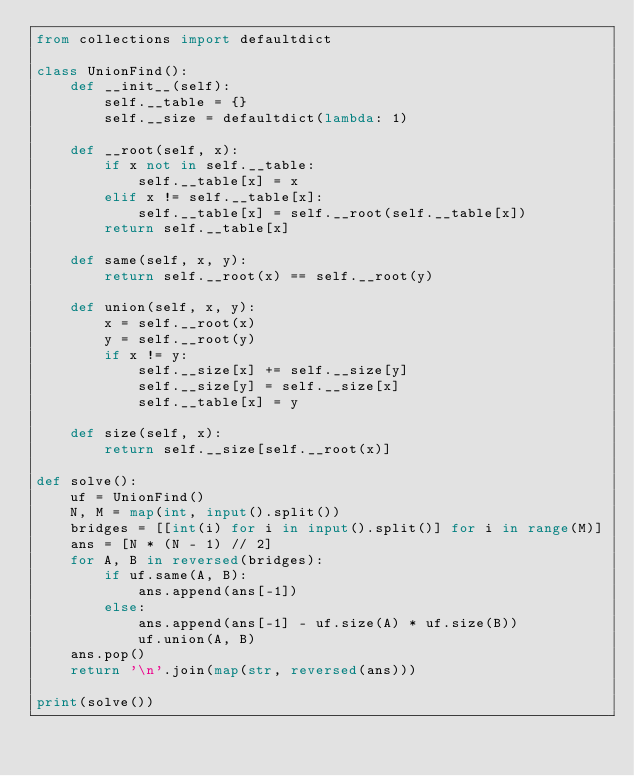Convert code to text. <code><loc_0><loc_0><loc_500><loc_500><_Python_>from collections import defaultdict

class UnionFind():
    def __init__(self):
        self.__table = {}
        self.__size = defaultdict(lambda: 1)

    def __root(self, x):
        if x not in self.__table:
            self.__table[x] = x
        elif x != self.__table[x]:
            self.__table[x] = self.__root(self.__table[x])
        return self.__table[x]

    def same(self, x, y):
        return self.__root(x) == self.__root(y)

    def union(self, x, y):
        x = self.__root(x)
        y = self.__root(y)
        if x != y:
            self.__size[x] += self.__size[y]
            self.__size[y] = self.__size[x]
            self.__table[x] = y

    def size(self, x):
        return self.__size[self.__root(x)]

def solve():
    uf = UnionFind()
    N, M = map(int, input().split())
    bridges = [[int(i) for i in input().split()] for i in range(M)]
    ans = [N * (N - 1) // 2]
    for A, B in reversed(bridges):
        if uf.same(A, B):
            ans.append(ans[-1])
        else:
            ans.append(ans[-1] - uf.size(A) * uf.size(B))
            uf.union(A, B)
    ans.pop()
    return '\n'.join(map(str, reversed(ans)))

print(solve())
</code> 